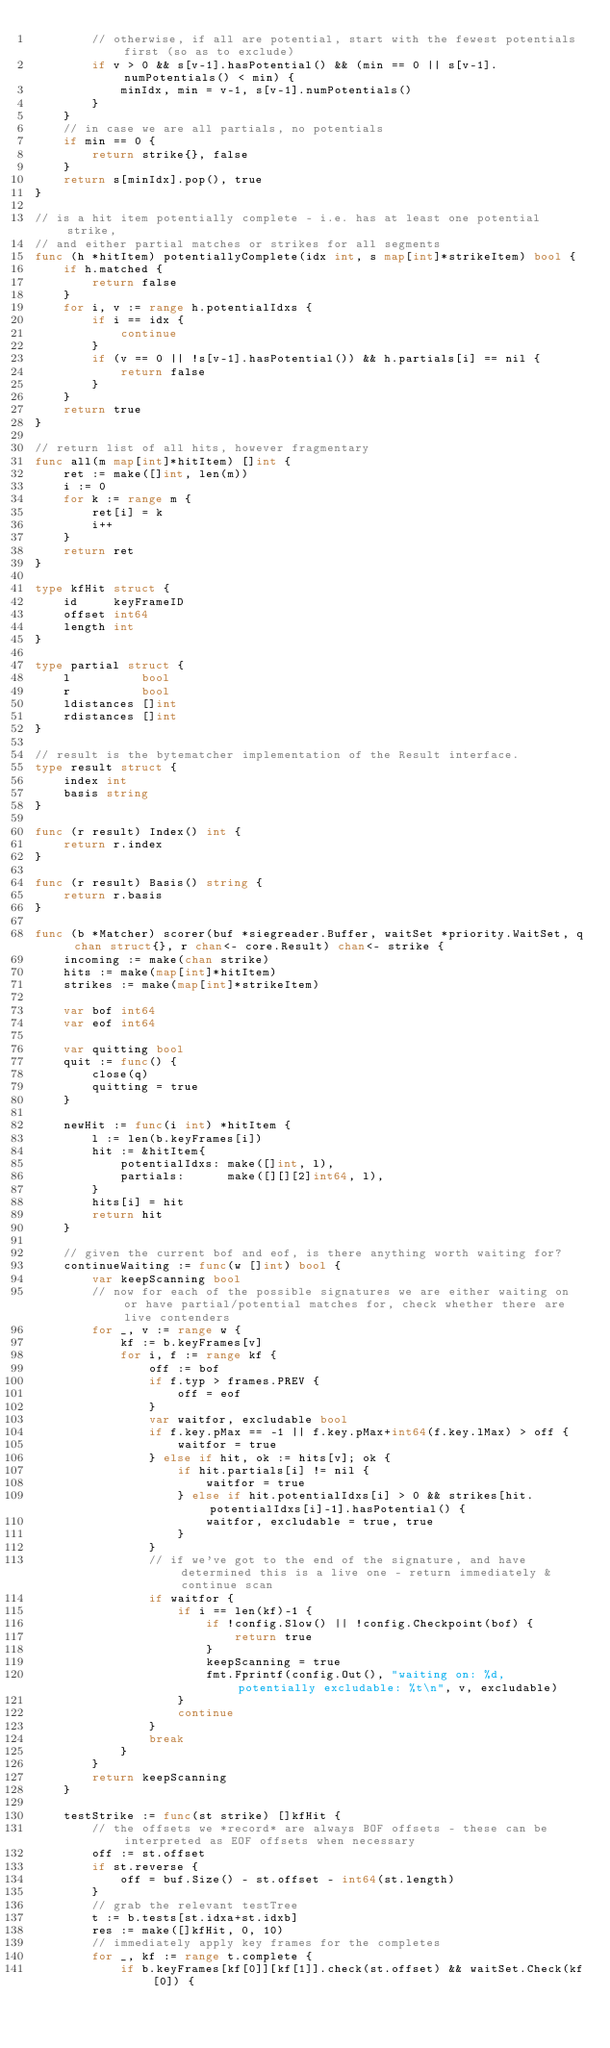Convert code to text. <code><loc_0><loc_0><loc_500><loc_500><_Go_>		// otherwise, if all are potential, start with the fewest potentials first (so as to exclude)
		if v > 0 && s[v-1].hasPotential() && (min == 0 || s[v-1].numPotentials() < min) {
			minIdx, min = v-1, s[v-1].numPotentials()
		}
	}
	// in case we are all partials, no potentials
	if min == 0 {
		return strike{}, false
	}
	return s[minIdx].pop(), true
}

// is a hit item potentially complete - i.e. has at least one potential strike,
// and either partial matches or strikes for all segments
func (h *hitItem) potentiallyComplete(idx int, s map[int]*strikeItem) bool {
	if h.matched {
		return false
	}
	for i, v := range h.potentialIdxs {
		if i == idx {
			continue
		}
		if (v == 0 || !s[v-1].hasPotential()) && h.partials[i] == nil {
			return false
		}
	}
	return true
}

// return list of all hits, however fragmentary
func all(m map[int]*hitItem) []int {
	ret := make([]int, len(m))
	i := 0
	for k := range m {
		ret[i] = k
		i++
	}
	return ret
}

type kfHit struct {
	id     keyFrameID
	offset int64
	length int
}

type partial struct {
	l          bool
	r          bool
	ldistances []int
	rdistances []int
}

// result is the bytematcher implementation of the Result interface.
type result struct {
	index int
	basis string
}

func (r result) Index() int {
	return r.index
}

func (r result) Basis() string {
	return r.basis
}

func (b *Matcher) scorer(buf *siegreader.Buffer, waitSet *priority.WaitSet, q chan struct{}, r chan<- core.Result) chan<- strike {
	incoming := make(chan strike)
	hits := make(map[int]*hitItem)
	strikes := make(map[int]*strikeItem)

	var bof int64
	var eof int64

	var quitting bool
	quit := func() {
		close(q)
		quitting = true
	}

	newHit := func(i int) *hitItem {
		l := len(b.keyFrames[i])
		hit := &hitItem{
			potentialIdxs: make([]int, l),
			partials:      make([][][2]int64, l),
		}
		hits[i] = hit
		return hit
	}

	// given the current bof and eof, is there anything worth waiting for?
	continueWaiting := func(w []int) bool {
		var keepScanning bool
		// now for each of the possible signatures we are either waiting on or have partial/potential matches for, check whether there are live contenders
		for _, v := range w {
			kf := b.keyFrames[v]
			for i, f := range kf {
				off := bof
				if f.typ > frames.PREV {
					off = eof
				}
				var waitfor, excludable bool
				if f.key.pMax == -1 || f.key.pMax+int64(f.key.lMax) > off {
					waitfor = true
				} else if hit, ok := hits[v]; ok {
					if hit.partials[i] != nil {
						waitfor = true
					} else if hit.potentialIdxs[i] > 0 && strikes[hit.potentialIdxs[i]-1].hasPotential() {
						waitfor, excludable = true, true
					}
				}
				// if we've got to the end of the signature, and have determined this is a live one - return immediately & continue scan
				if waitfor {
					if i == len(kf)-1 {
						if !config.Slow() || !config.Checkpoint(bof) {
							return true
						}
						keepScanning = true
						fmt.Fprintf(config.Out(), "waiting on: %d, potentially excludable: %t\n", v, excludable)
					}
					continue
				}
				break
			}
		}
		return keepScanning
	}

	testStrike := func(st strike) []kfHit {
		// the offsets we *record* are always BOF offsets - these can be interpreted as EOF offsets when necessary
		off := st.offset
		if st.reverse {
			off = buf.Size() - st.offset - int64(st.length)
		}
		// grab the relevant testTree
		t := b.tests[st.idxa+st.idxb]
		res := make([]kfHit, 0, 10)
		// immediately apply key frames for the completes
		for _, kf := range t.complete {
			if b.keyFrames[kf[0]][kf[1]].check(st.offset) && waitSet.Check(kf[0]) {</code> 